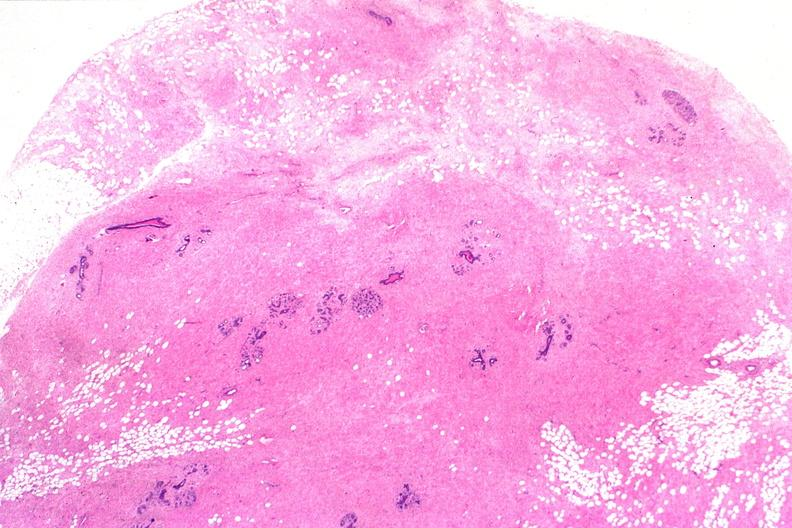what is present?
Answer the question using a single word or phrase. Female reproductive 